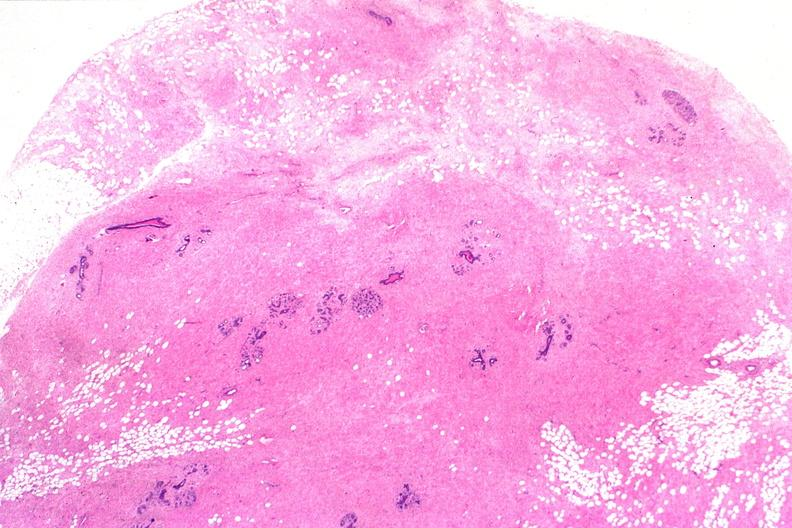what is present?
Answer the question using a single word or phrase. Female reproductive 